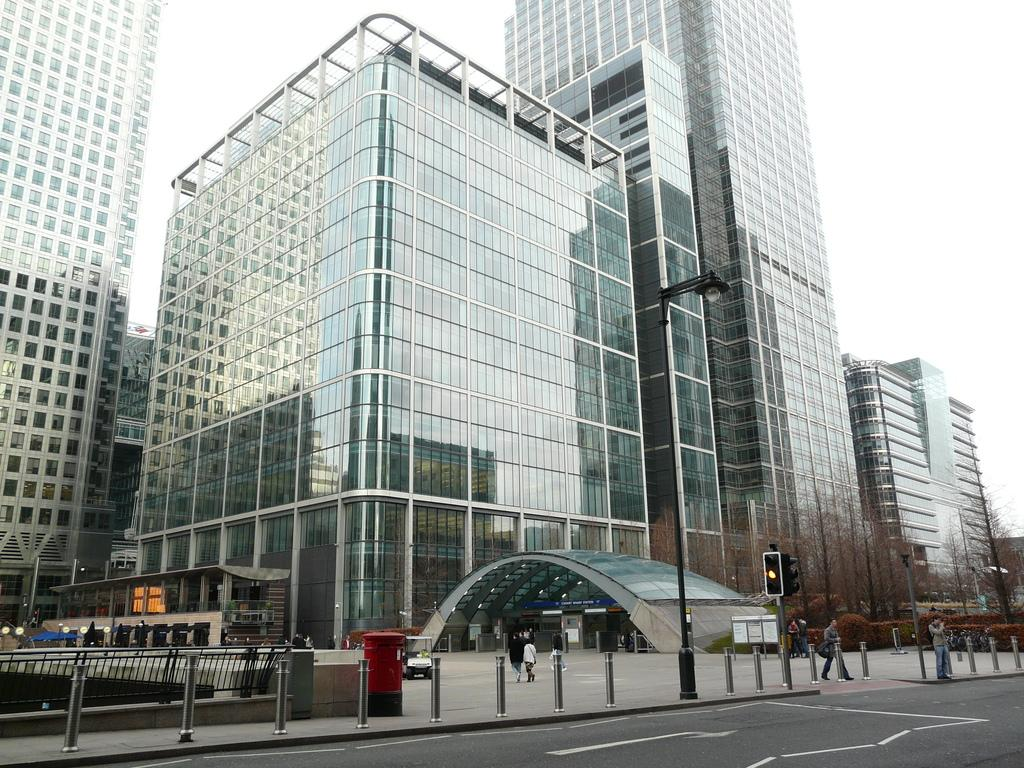What is located at the bottom of the image? There are trees, persons, a road, and traffic signals at the bottom of the image. What can be seen in the center of the image? There are buildings in the center of the image. What is visible in the background of the image? The sky is visible in the background of the image. What type of floor can be seen in the image? There is no floor visible in the image; it features a road, trees, buildings, and the sky. What emotion are the persons in the image expressing? The provided facts do not mention any emotions or expressions of the persons in the image. 